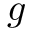<formula> <loc_0><loc_0><loc_500><loc_500>g</formula> 